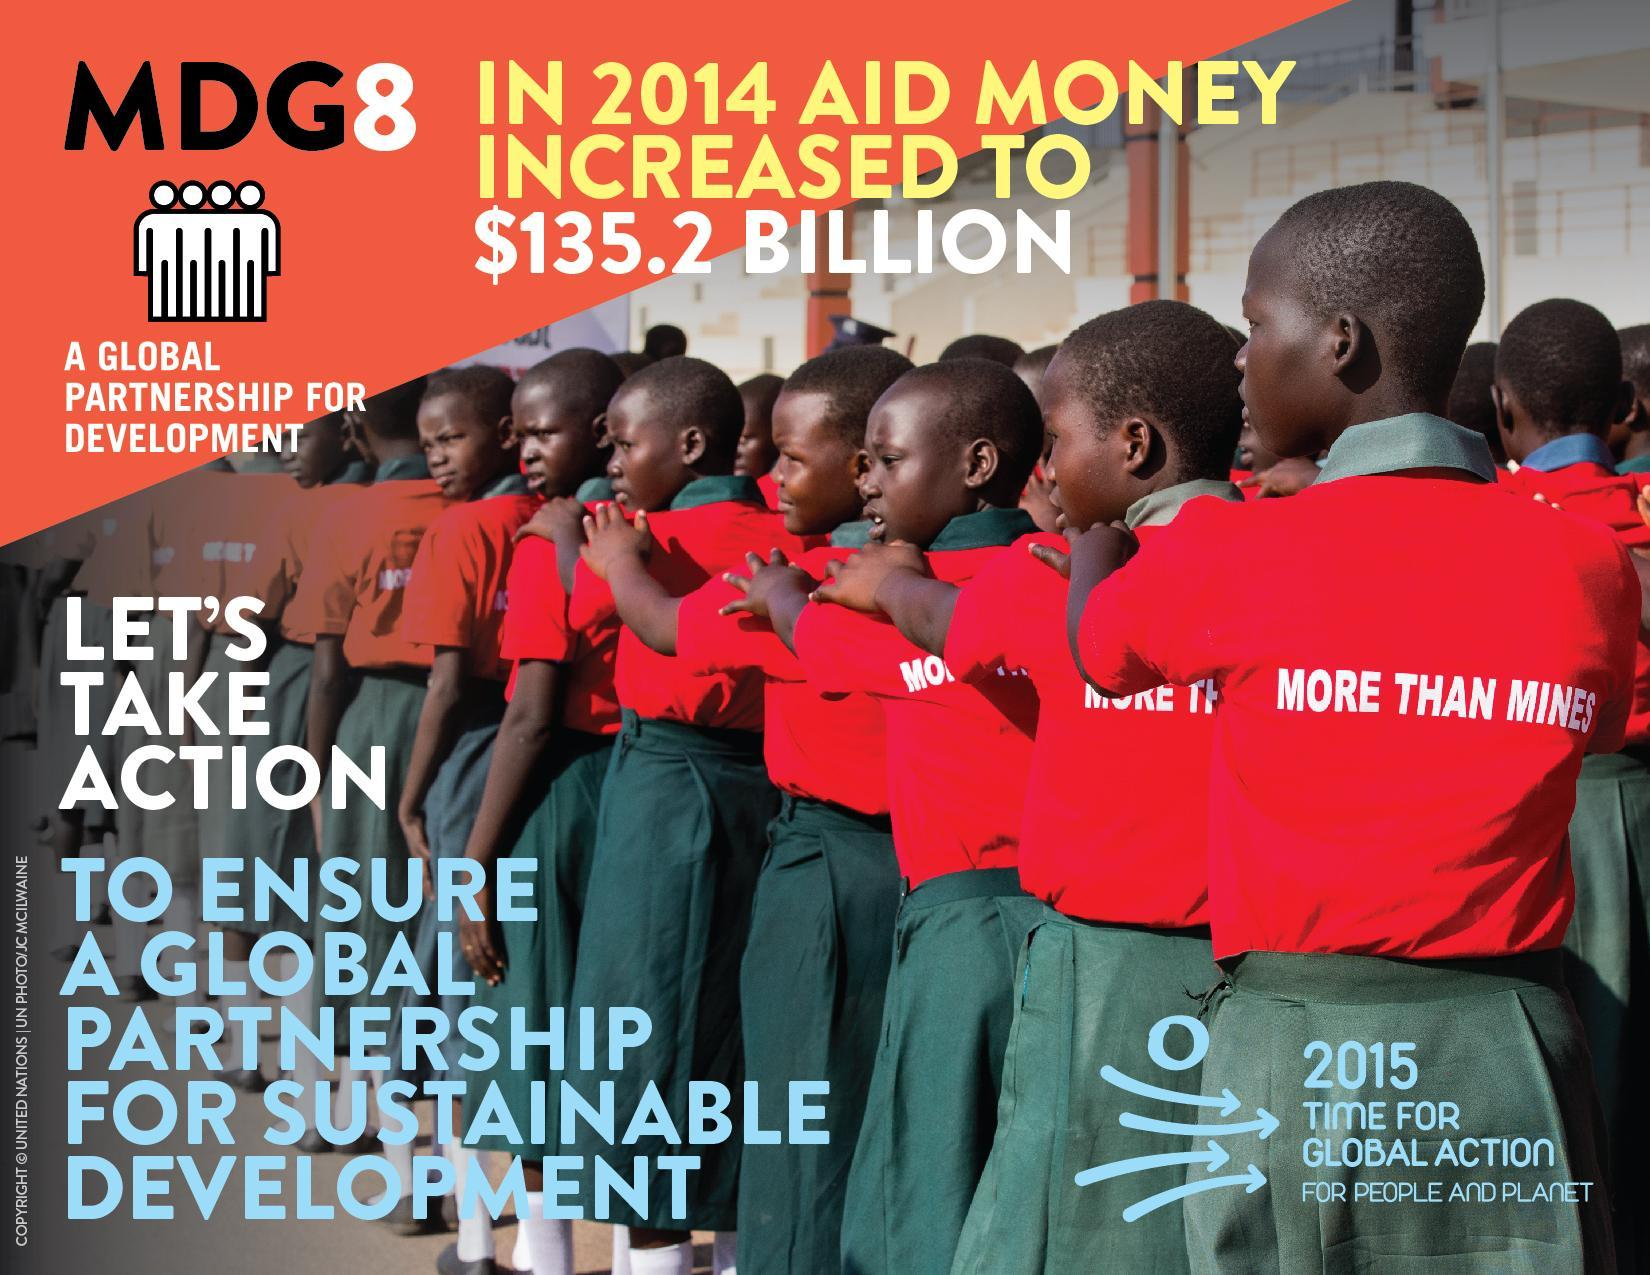What is the message on the T-shirts of the children?
Answer the question with a short phrase. More Than Mines 